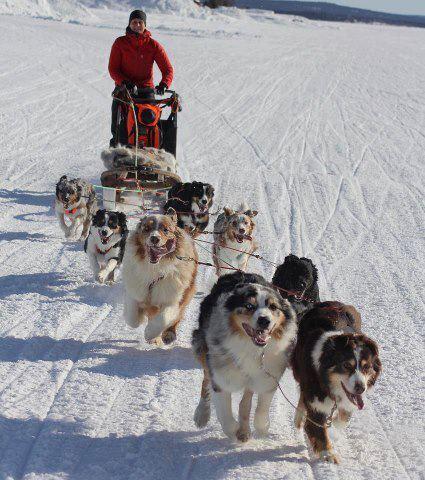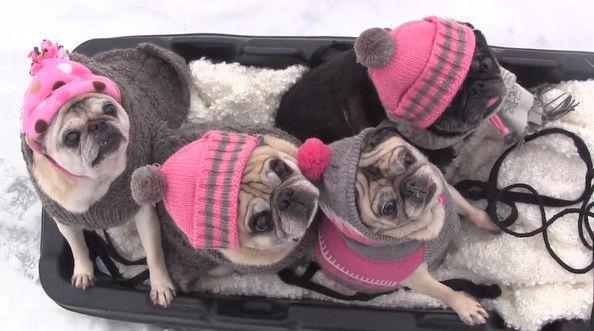The first image is the image on the left, the second image is the image on the right. Given the left and right images, does the statement "There are exactly 8 pugs sitting in a sled wearing hats." hold true? Answer yes or no. No. The first image is the image on the left, the second image is the image on the right. For the images shown, is this caption "there is a human in the image on the left" true? Answer yes or no. Yes. 